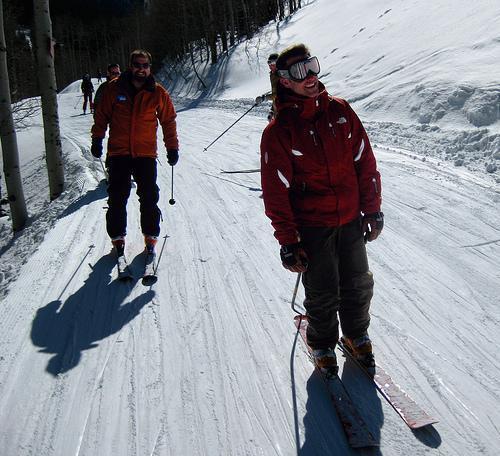How many people are there?
Give a very brief answer. 6. 